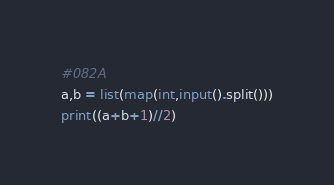Convert code to text. <code><loc_0><loc_0><loc_500><loc_500><_Python_>#082A
a,b = list(map(int,input().split()))
print((a+b+1)//2)</code> 